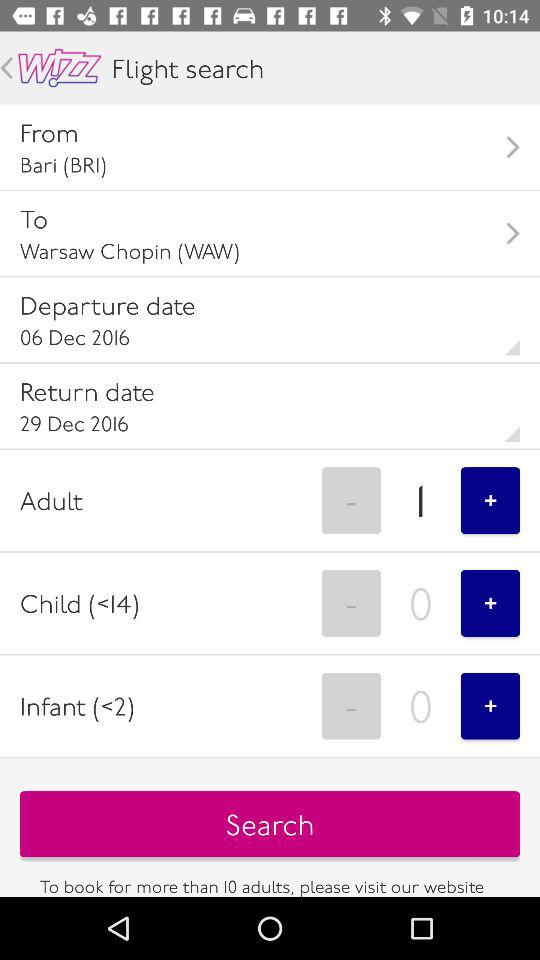How many adults are currently selected?
Answer the question using a single word or phrase. 1 